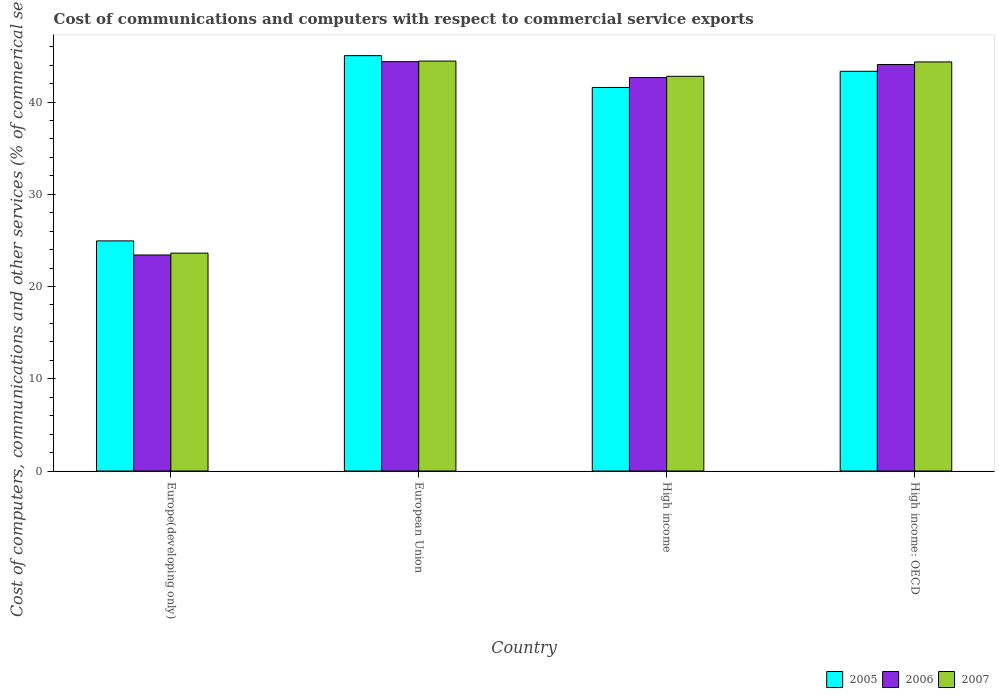How many groups of bars are there?
Give a very brief answer. 4. Are the number of bars per tick equal to the number of legend labels?
Your answer should be very brief. Yes. In how many cases, is the number of bars for a given country not equal to the number of legend labels?
Your answer should be very brief. 0. What is the cost of communications and computers in 2007 in European Union?
Ensure brevity in your answer.  44.44. Across all countries, what is the maximum cost of communications and computers in 2007?
Offer a terse response. 44.44. Across all countries, what is the minimum cost of communications and computers in 2007?
Give a very brief answer. 23.62. In which country was the cost of communications and computers in 2007 maximum?
Keep it short and to the point. European Union. In which country was the cost of communications and computers in 2005 minimum?
Your response must be concise. Europe(developing only). What is the total cost of communications and computers in 2007 in the graph?
Provide a succinct answer. 155.21. What is the difference between the cost of communications and computers in 2005 in Europe(developing only) and that in European Union?
Ensure brevity in your answer.  -20.08. What is the difference between the cost of communications and computers in 2007 in High income: OECD and the cost of communications and computers in 2006 in European Union?
Offer a very short reply. -0.03. What is the average cost of communications and computers in 2005 per country?
Offer a terse response. 38.72. What is the difference between the cost of communications and computers of/in 2006 and cost of communications and computers of/in 2005 in High income: OECD?
Ensure brevity in your answer.  0.74. What is the ratio of the cost of communications and computers in 2007 in Europe(developing only) to that in European Union?
Ensure brevity in your answer.  0.53. Is the cost of communications and computers in 2006 in High income less than that in High income: OECD?
Your answer should be very brief. Yes. Is the difference between the cost of communications and computers in 2006 in European Union and High income greater than the difference between the cost of communications and computers in 2005 in European Union and High income?
Provide a succinct answer. No. What is the difference between the highest and the second highest cost of communications and computers in 2005?
Keep it short and to the point. -1.76. What is the difference between the highest and the lowest cost of communications and computers in 2005?
Give a very brief answer. 20.08. In how many countries, is the cost of communications and computers in 2007 greater than the average cost of communications and computers in 2007 taken over all countries?
Make the answer very short. 3. What does the 1st bar from the right in High income: OECD represents?
Provide a succinct answer. 2007. Are all the bars in the graph horizontal?
Ensure brevity in your answer.  No. Does the graph contain grids?
Provide a succinct answer. No. How many legend labels are there?
Ensure brevity in your answer.  3. What is the title of the graph?
Your answer should be very brief. Cost of communications and computers with respect to commercial service exports. What is the label or title of the X-axis?
Ensure brevity in your answer.  Country. What is the label or title of the Y-axis?
Your response must be concise. Cost of computers, communications and other services (% of commerical service exports). What is the Cost of computers, communications and other services (% of commerical service exports) of 2005 in Europe(developing only)?
Your answer should be very brief. 24.95. What is the Cost of computers, communications and other services (% of commerical service exports) in 2006 in Europe(developing only)?
Offer a terse response. 23.42. What is the Cost of computers, communications and other services (% of commerical service exports) in 2007 in Europe(developing only)?
Provide a succinct answer. 23.62. What is the Cost of computers, communications and other services (% of commerical service exports) of 2005 in European Union?
Provide a succinct answer. 45.03. What is the Cost of computers, communications and other services (% of commerical service exports) in 2006 in European Union?
Your response must be concise. 44.38. What is the Cost of computers, communications and other services (% of commerical service exports) of 2007 in European Union?
Your answer should be compact. 44.44. What is the Cost of computers, communications and other services (% of commerical service exports) in 2005 in High income?
Your response must be concise. 41.58. What is the Cost of computers, communications and other services (% of commerical service exports) in 2006 in High income?
Provide a succinct answer. 42.66. What is the Cost of computers, communications and other services (% of commerical service exports) of 2007 in High income?
Keep it short and to the point. 42.79. What is the Cost of computers, communications and other services (% of commerical service exports) of 2005 in High income: OECD?
Make the answer very short. 43.34. What is the Cost of computers, communications and other services (% of commerical service exports) of 2006 in High income: OECD?
Give a very brief answer. 44.07. What is the Cost of computers, communications and other services (% of commerical service exports) in 2007 in High income: OECD?
Ensure brevity in your answer.  44.35. Across all countries, what is the maximum Cost of computers, communications and other services (% of commerical service exports) of 2005?
Give a very brief answer. 45.03. Across all countries, what is the maximum Cost of computers, communications and other services (% of commerical service exports) of 2006?
Your answer should be compact. 44.38. Across all countries, what is the maximum Cost of computers, communications and other services (% of commerical service exports) in 2007?
Make the answer very short. 44.44. Across all countries, what is the minimum Cost of computers, communications and other services (% of commerical service exports) in 2005?
Your response must be concise. 24.95. Across all countries, what is the minimum Cost of computers, communications and other services (% of commerical service exports) of 2006?
Your answer should be compact. 23.42. Across all countries, what is the minimum Cost of computers, communications and other services (% of commerical service exports) in 2007?
Your response must be concise. 23.62. What is the total Cost of computers, communications and other services (% of commerical service exports) in 2005 in the graph?
Your response must be concise. 154.9. What is the total Cost of computers, communications and other services (% of commerical service exports) in 2006 in the graph?
Your answer should be very brief. 154.53. What is the total Cost of computers, communications and other services (% of commerical service exports) in 2007 in the graph?
Provide a succinct answer. 155.21. What is the difference between the Cost of computers, communications and other services (% of commerical service exports) in 2005 in Europe(developing only) and that in European Union?
Keep it short and to the point. -20.08. What is the difference between the Cost of computers, communications and other services (% of commerical service exports) in 2006 in Europe(developing only) and that in European Union?
Your answer should be very brief. -20.96. What is the difference between the Cost of computers, communications and other services (% of commerical service exports) in 2007 in Europe(developing only) and that in European Union?
Provide a succinct answer. -20.82. What is the difference between the Cost of computers, communications and other services (% of commerical service exports) of 2005 in Europe(developing only) and that in High income?
Give a very brief answer. -16.64. What is the difference between the Cost of computers, communications and other services (% of commerical service exports) of 2006 in Europe(developing only) and that in High income?
Your response must be concise. -19.23. What is the difference between the Cost of computers, communications and other services (% of commerical service exports) of 2007 in Europe(developing only) and that in High income?
Offer a very short reply. -19.17. What is the difference between the Cost of computers, communications and other services (% of commerical service exports) in 2005 in Europe(developing only) and that in High income: OECD?
Make the answer very short. -18.39. What is the difference between the Cost of computers, communications and other services (% of commerical service exports) in 2006 in Europe(developing only) and that in High income: OECD?
Offer a terse response. -20.65. What is the difference between the Cost of computers, communications and other services (% of commerical service exports) in 2007 in Europe(developing only) and that in High income: OECD?
Keep it short and to the point. -20.73. What is the difference between the Cost of computers, communications and other services (% of commerical service exports) of 2005 in European Union and that in High income?
Offer a terse response. 3.45. What is the difference between the Cost of computers, communications and other services (% of commerical service exports) of 2006 in European Union and that in High income?
Offer a terse response. 1.72. What is the difference between the Cost of computers, communications and other services (% of commerical service exports) of 2007 in European Union and that in High income?
Keep it short and to the point. 1.65. What is the difference between the Cost of computers, communications and other services (% of commerical service exports) of 2005 in European Union and that in High income: OECD?
Your answer should be compact. 1.69. What is the difference between the Cost of computers, communications and other services (% of commerical service exports) of 2006 in European Union and that in High income: OECD?
Make the answer very short. 0.31. What is the difference between the Cost of computers, communications and other services (% of commerical service exports) in 2007 in European Union and that in High income: OECD?
Your response must be concise. 0.09. What is the difference between the Cost of computers, communications and other services (% of commerical service exports) in 2005 in High income and that in High income: OECD?
Offer a terse response. -1.76. What is the difference between the Cost of computers, communications and other services (% of commerical service exports) in 2006 in High income and that in High income: OECD?
Make the answer very short. -1.42. What is the difference between the Cost of computers, communications and other services (% of commerical service exports) of 2007 in High income and that in High income: OECD?
Your answer should be very brief. -1.56. What is the difference between the Cost of computers, communications and other services (% of commerical service exports) in 2005 in Europe(developing only) and the Cost of computers, communications and other services (% of commerical service exports) in 2006 in European Union?
Your answer should be compact. -19.43. What is the difference between the Cost of computers, communications and other services (% of commerical service exports) in 2005 in Europe(developing only) and the Cost of computers, communications and other services (% of commerical service exports) in 2007 in European Union?
Your response must be concise. -19.5. What is the difference between the Cost of computers, communications and other services (% of commerical service exports) of 2006 in Europe(developing only) and the Cost of computers, communications and other services (% of commerical service exports) of 2007 in European Union?
Offer a terse response. -21.02. What is the difference between the Cost of computers, communications and other services (% of commerical service exports) in 2005 in Europe(developing only) and the Cost of computers, communications and other services (% of commerical service exports) in 2006 in High income?
Make the answer very short. -17.71. What is the difference between the Cost of computers, communications and other services (% of commerical service exports) in 2005 in Europe(developing only) and the Cost of computers, communications and other services (% of commerical service exports) in 2007 in High income?
Ensure brevity in your answer.  -17.85. What is the difference between the Cost of computers, communications and other services (% of commerical service exports) of 2006 in Europe(developing only) and the Cost of computers, communications and other services (% of commerical service exports) of 2007 in High income?
Ensure brevity in your answer.  -19.37. What is the difference between the Cost of computers, communications and other services (% of commerical service exports) in 2005 in Europe(developing only) and the Cost of computers, communications and other services (% of commerical service exports) in 2006 in High income: OECD?
Your response must be concise. -19.13. What is the difference between the Cost of computers, communications and other services (% of commerical service exports) in 2005 in Europe(developing only) and the Cost of computers, communications and other services (% of commerical service exports) in 2007 in High income: OECD?
Make the answer very short. -19.4. What is the difference between the Cost of computers, communications and other services (% of commerical service exports) of 2006 in Europe(developing only) and the Cost of computers, communications and other services (% of commerical service exports) of 2007 in High income: OECD?
Your response must be concise. -20.93. What is the difference between the Cost of computers, communications and other services (% of commerical service exports) in 2005 in European Union and the Cost of computers, communications and other services (% of commerical service exports) in 2006 in High income?
Give a very brief answer. 2.38. What is the difference between the Cost of computers, communications and other services (% of commerical service exports) in 2005 in European Union and the Cost of computers, communications and other services (% of commerical service exports) in 2007 in High income?
Make the answer very short. 2.24. What is the difference between the Cost of computers, communications and other services (% of commerical service exports) in 2006 in European Union and the Cost of computers, communications and other services (% of commerical service exports) in 2007 in High income?
Keep it short and to the point. 1.59. What is the difference between the Cost of computers, communications and other services (% of commerical service exports) in 2005 in European Union and the Cost of computers, communications and other services (% of commerical service exports) in 2006 in High income: OECD?
Make the answer very short. 0.96. What is the difference between the Cost of computers, communications and other services (% of commerical service exports) in 2005 in European Union and the Cost of computers, communications and other services (% of commerical service exports) in 2007 in High income: OECD?
Offer a very short reply. 0.68. What is the difference between the Cost of computers, communications and other services (% of commerical service exports) in 2006 in European Union and the Cost of computers, communications and other services (% of commerical service exports) in 2007 in High income: OECD?
Provide a short and direct response. 0.03. What is the difference between the Cost of computers, communications and other services (% of commerical service exports) of 2005 in High income and the Cost of computers, communications and other services (% of commerical service exports) of 2006 in High income: OECD?
Make the answer very short. -2.49. What is the difference between the Cost of computers, communications and other services (% of commerical service exports) in 2005 in High income and the Cost of computers, communications and other services (% of commerical service exports) in 2007 in High income: OECD?
Make the answer very short. -2.77. What is the difference between the Cost of computers, communications and other services (% of commerical service exports) in 2006 in High income and the Cost of computers, communications and other services (% of commerical service exports) in 2007 in High income: OECD?
Offer a terse response. -1.7. What is the average Cost of computers, communications and other services (% of commerical service exports) in 2005 per country?
Make the answer very short. 38.72. What is the average Cost of computers, communications and other services (% of commerical service exports) of 2006 per country?
Your answer should be very brief. 38.63. What is the average Cost of computers, communications and other services (% of commerical service exports) of 2007 per country?
Your answer should be very brief. 38.8. What is the difference between the Cost of computers, communications and other services (% of commerical service exports) of 2005 and Cost of computers, communications and other services (% of commerical service exports) of 2006 in Europe(developing only)?
Ensure brevity in your answer.  1.53. What is the difference between the Cost of computers, communications and other services (% of commerical service exports) in 2005 and Cost of computers, communications and other services (% of commerical service exports) in 2007 in Europe(developing only)?
Your answer should be very brief. 1.33. What is the difference between the Cost of computers, communications and other services (% of commerical service exports) of 2006 and Cost of computers, communications and other services (% of commerical service exports) of 2007 in Europe(developing only)?
Offer a terse response. -0.2. What is the difference between the Cost of computers, communications and other services (% of commerical service exports) of 2005 and Cost of computers, communications and other services (% of commerical service exports) of 2006 in European Union?
Make the answer very short. 0.65. What is the difference between the Cost of computers, communications and other services (% of commerical service exports) of 2005 and Cost of computers, communications and other services (% of commerical service exports) of 2007 in European Union?
Ensure brevity in your answer.  0.59. What is the difference between the Cost of computers, communications and other services (% of commerical service exports) of 2006 and Cost of computers, communications and other services (% of commerical service exports) of 2007 in European Union?
Provide a succinct answer. -0.06. What is the difference between the Cost of computers, communications and other services (% of commerical service exports) of 2005 and Cost of computers, communications and other services (% of commerical service exports) of 2006 in High income?
Offer a very short reply. -1.07. What is the difference between the Cost of computers, communications and other services (% of commerical service exports) in 2005 and Cost of computers, communications and other services (% of commerical service exports) in 2007 in High income?
Give a very brief answer. -1.21. What is the difference between the Cost of computers, communications and other services (% of commerical service exports) in 2006 and Cost of computers, communications and other services (% of commerical service exports) in 2007 in High income?
Keep it short and to the point. -0.14. What is the difference between the Cost of computers, communications and other services (% of commerical service exports) of 2005 and Cost of computers, communications and other services (% of commerical service exports) of 2006 in High income: OECD?
Your response must be concise. -0.74. What is the difference between the Cost of computers, communications and other services (% of commerical service exports) in 2005 and Cost of computers, communications and other services (% of commerical service exports) in 2007 in High income: OECD?
Provide a succinct answer. -1.01. What is the difference between the Cost of computers, communications and other services (% of commerical service exports) of 2006 and Cost of computers, communications and other services (% of commerical service exports) of 2007 in High income: OECD?
Your response must be concise. -0.28. What is the ratio of the Cost of computers, communications and other services (% of commerical service exports) of 2005 in Europe(developing only) to that in European Union?
Keep it short and to the point. 0.55. What is the ratio of the Cost of computers, communications and other services (% of commerical service exports) of 2006 in Europe(developing only) to that in European Union?
Your answer should be compact. 0.53. What is the ratio of the Cost of computers, communications and other services (% of commerical service exports) of 2007 in Europe(developing only) to that in European Union?
Offer a very short reply. 0.53. What is the ratio of the Cost of computers, communications and other services (% of commerical service exports) of 2005 in Europe(developing only) to that in High income?
Make the answer very short. 0.6. What is the ratio of the Cost of computers, communications and other services (% of commerical service exports) of 2006 in Europe(developing only) to that in High income?
Keep it short and to the point. 0.55. What is the ratio of the Cost of computers, communications and other services (% of commerical service exports) in 2007 in Europe(developing only) to that in High income?
Your answer should be very brief. 0.55. What is the ratio of the Cost of computers, communications and other services (% of commerical service exports) of 2005 in Europe(developing only) to that in High income: OECD?
Your answer should be very brief. 0.58. What is the ratio of the Cost of computers, communications and other services (% of commerical service exports) of 2006 in Europe(developing only) to that in High income: OECD?
Give a very brief answer. 0.53. What is the ratio of the Cost of computers, communications and other services (% of commerical service exports) of 2007 in Europe(developing only) to that in High income: OECD?
Provide a succinct answer. 0.53. What is the ratio of the Cost of computers, communications and other services (% of commerical service exports) of 2005 in European Union to that in High income?
Your answer should be very brief. 1.08. What is the ratio of the Cost of computers, communications and other services (% of commerical service exports) of 2006 in European Union to that in High income?
Offer a terse response. 1.04. What is the ratio of the Cost of computers, communications and other services (% of commerical service exports) of 2007 in European Union to that in High income?
Keep it short and to the point. 1.04. What is the ratio of the Cost of computers, communications and other services (% of commerical service exports) of 2005 in European Union to that in High income: OECD?
Make the answer very short. 1.04. What is the ratio of the Cost of computers, communications and other services (% of commerical service exports) of 2006 in European Union to that in High income: OECD?
Offer a very short reply. 1.01. What is the ratio of the Cost of computers, communications and other services (% of commerical service exports) in 2007 in European Union to that in High income: OECD?
Offer a very short reply. 1. What is the ratio of the Cost of computers, communications and other services (% of commerical service exports) in 2005 in High income to that in High income: OECD?
Provide a short and direct response. 0.96. What is the ratio of the Cost of computers, communications and other services (% of commerical service exports) in 2006 in High income to that in High income: OECD?
Keep it short and to the point. 0.97. What is the ratio of the Cost of computers, communications and other services (% of commerical service exports) in 2007 in High income to that in High income: OECD?
Offer a very short reply. 0.96. What is the difference between the highest and the second highest Cost of computers, communications and other services (% of commerical service exports) in 2005?
Offer a very short reply. 1.69. What is the difference between the highest and the second highest Cost of computers, communications and other services (% of commerical service exports) of 2006?
Offer a very short reply. 0.31. What is the difference between the highest and the second highest Cost of computers, communications and other services (% of commerical service exports) of 2007?
Your response must be concise. 0.09. What is the difference between the highest and the lowest Cost of computers, communications and other services (% of commerical service exports) of 2005?
Give a very brief answer. 20.08. What is the difference between the highest and the lowest Cost of computers, communications and other services (% of commerical service exports) of 2006?
Your answer should be very brief. 20.96. What is the difference between the highest and the lowest Cost of computers, communications and other services (% of commerical service exports) in 2007?
Make the answer very short. 20.82. 